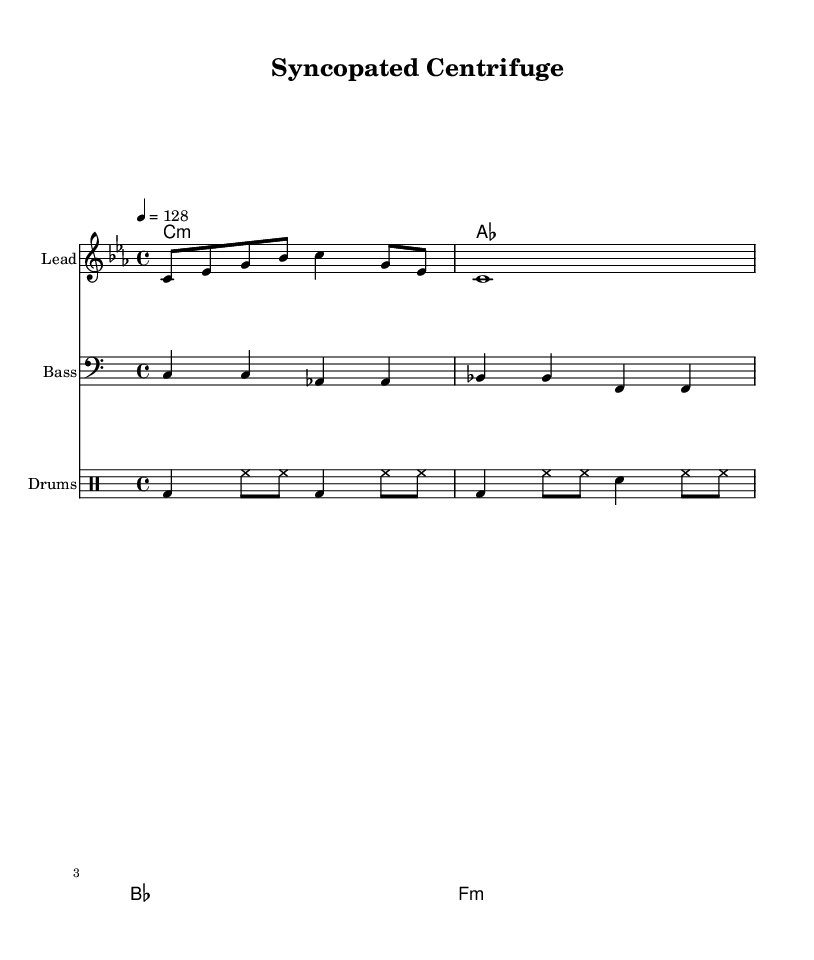What is the key signature of this music? The key signature is indicated by the presence of three flats, which corresponds to C minor.
Answer: C minor What is the time signature of the piece? The time signature is located at the beginning of the staff, showing there are four beats per measure, with each beat being a quarter note. This is indicated by the "4/4" notation.
Answer: 4/4 What is the tempo marking of the composition? The tempo marking appears in numerical form near the beginning of the score, stating that the piece should be played at 128 beats per minute.
Answer: 128 How many measures are in the melody? The melody is composed of two measures; this can be determined by counting the groupings of notes and rests in that part of the score.
Answer: 2 What type of rhythm is predominantly featured in the drums section? The rhythm pattern in the drums uses a combination of kick drum and hi-hat, primarily in 4/4 structure, which is a common rhythm in dance music.
Answer: Syncopated What is the function of the bass line in this composition? The bass line serves as the rhythmic foundation supporting the harmony and melody above it, typically outlining the chord changes while providing a groove.
Answer: Foundation What are the main instruments used in this composition? The score includes parts for lead (melody), bass (bass line), and drums, each indicated by their respective staff for distinct instruments.
Answer: Lead, Bass, Drums 